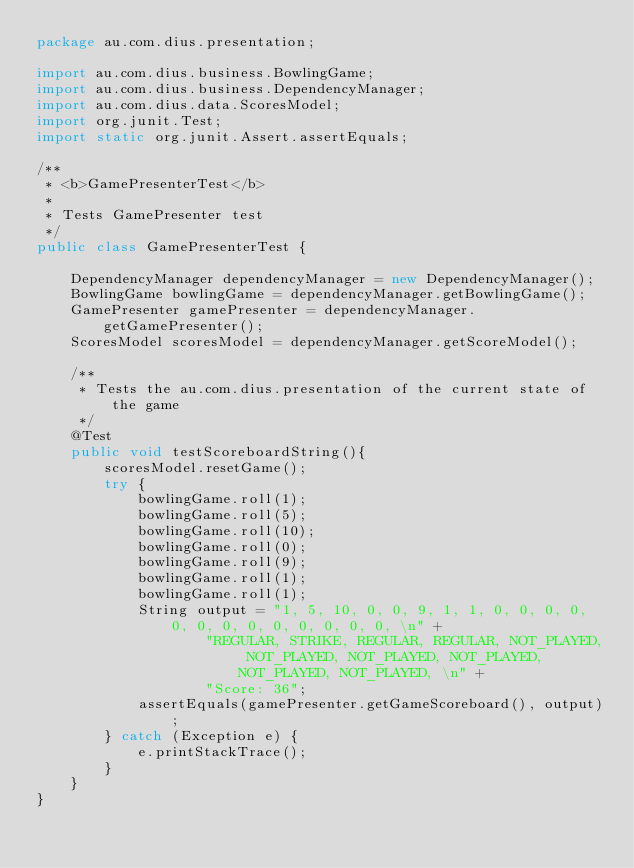<code> <loc_0><loc_0><loc_500><loc_500><_Java_>package au.com.dius.presentation;

import au.com.dius.business.BowlingGame;
import au.com.dius.business.DependencyManager;
import au.com.dius.data.ScoresModel;
import org.junit.Test;
import static org.junit.Assert.assertEquals;

/**
 * <b>GamePresenterTest</b>
 *
 * Tests GamePresenter test
 */
public class GamePresenterTest {

    DependencyManager dependencyManager = new DependencyManager();
    BowlingGame bowlingGame = dependencyManager.getBowlingGame();
    GamePresenter gamePresenter = dependencyManager.getGamePresenter();
    ScoresModel scoresModel = dependencyManager.getScoreModel();

    /**
     * Tests the au.com.dius.presentation of the current state of the game
     */
    @Test
    public void testScoreboardString(){
        scoresModel.resetGame();
        try {
            bowlingGame.roll(1);
            bowlingGame.roll(5);
            bowlingGame.roll(10);
            bowlingGame.roll(0);
            bowlingGame.roll(9);
            bowlingGame.roll(1);
            bowlingGame.roll(1);
            String output = "1, 5, 10, 0, 0, 9, 1, 1, 0, 0, 0, 0, 0, 0, 0, 0, 0, 0, 0, 0, 0, \n" +
                    "REGULAR, STRIKE, REGULAR, REGULAR, NOT_PLAYED, NOT_PLAYED, NOT_PLAYED, NOT_PLAYED, NOT_PLAYED, NOT_PLAYED, \n" +
                    "Score: 36";
            assertEquals(gamePresenter.getGameScoreboard(), output);
        } catch (Exception e) {
            e.printStackTrace();
        }
    }
}
</code> 